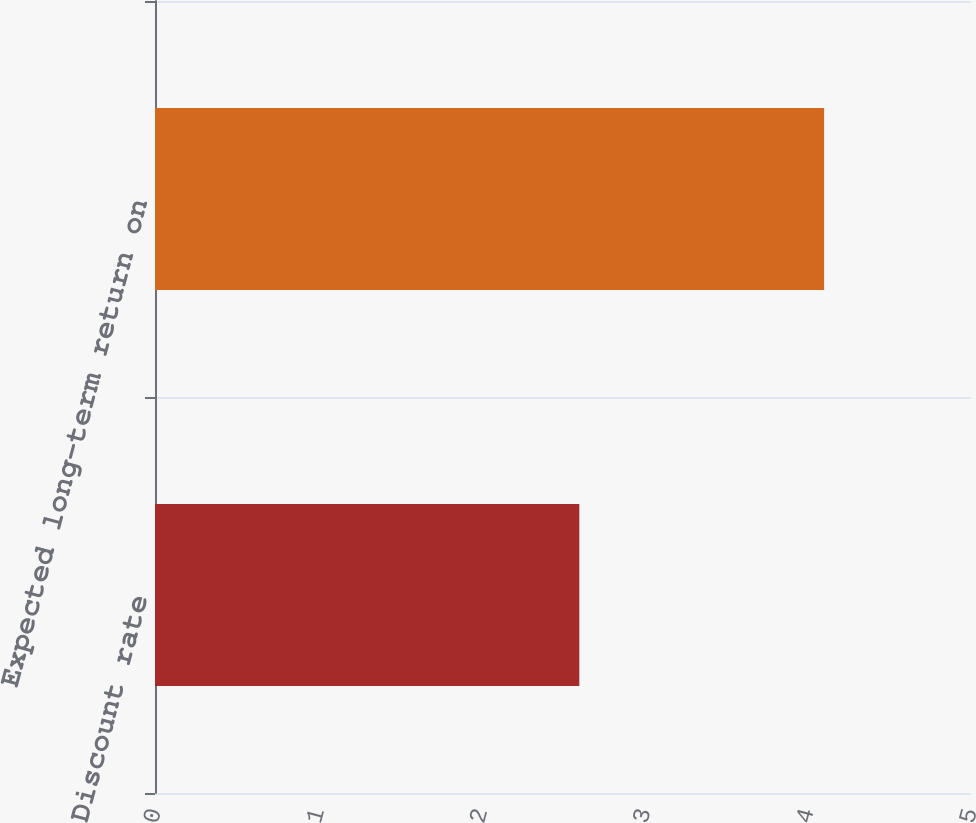Convert chart. <chart><loc_0><loc_0><loc_500><loc_500><bar_chart><fcel>Discount rate<fcel>Expected long-term return on<nl><fcel>2.6<fcel>4.1<nl></chart> 